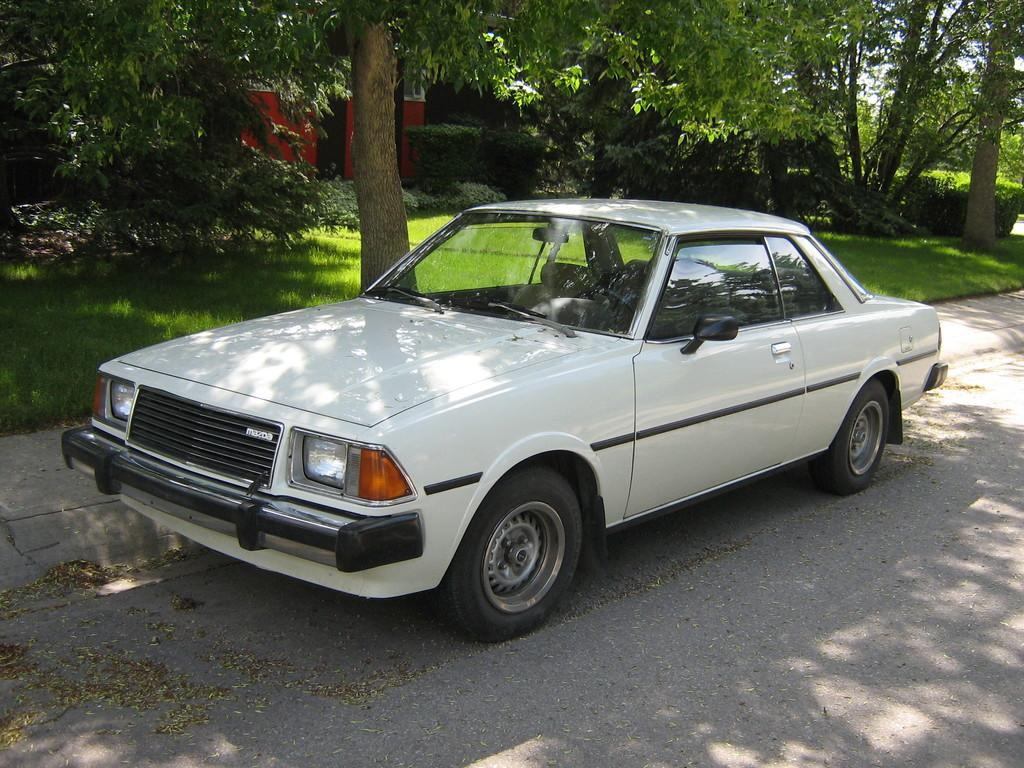What is the main subject of the image? The main subject of the image is a car on the road. What can be seen in the background of the image? There is grass and trees visible in the background of the image. Can you see a maid holding a gun in the image? There is no maid or gun present in the image. 